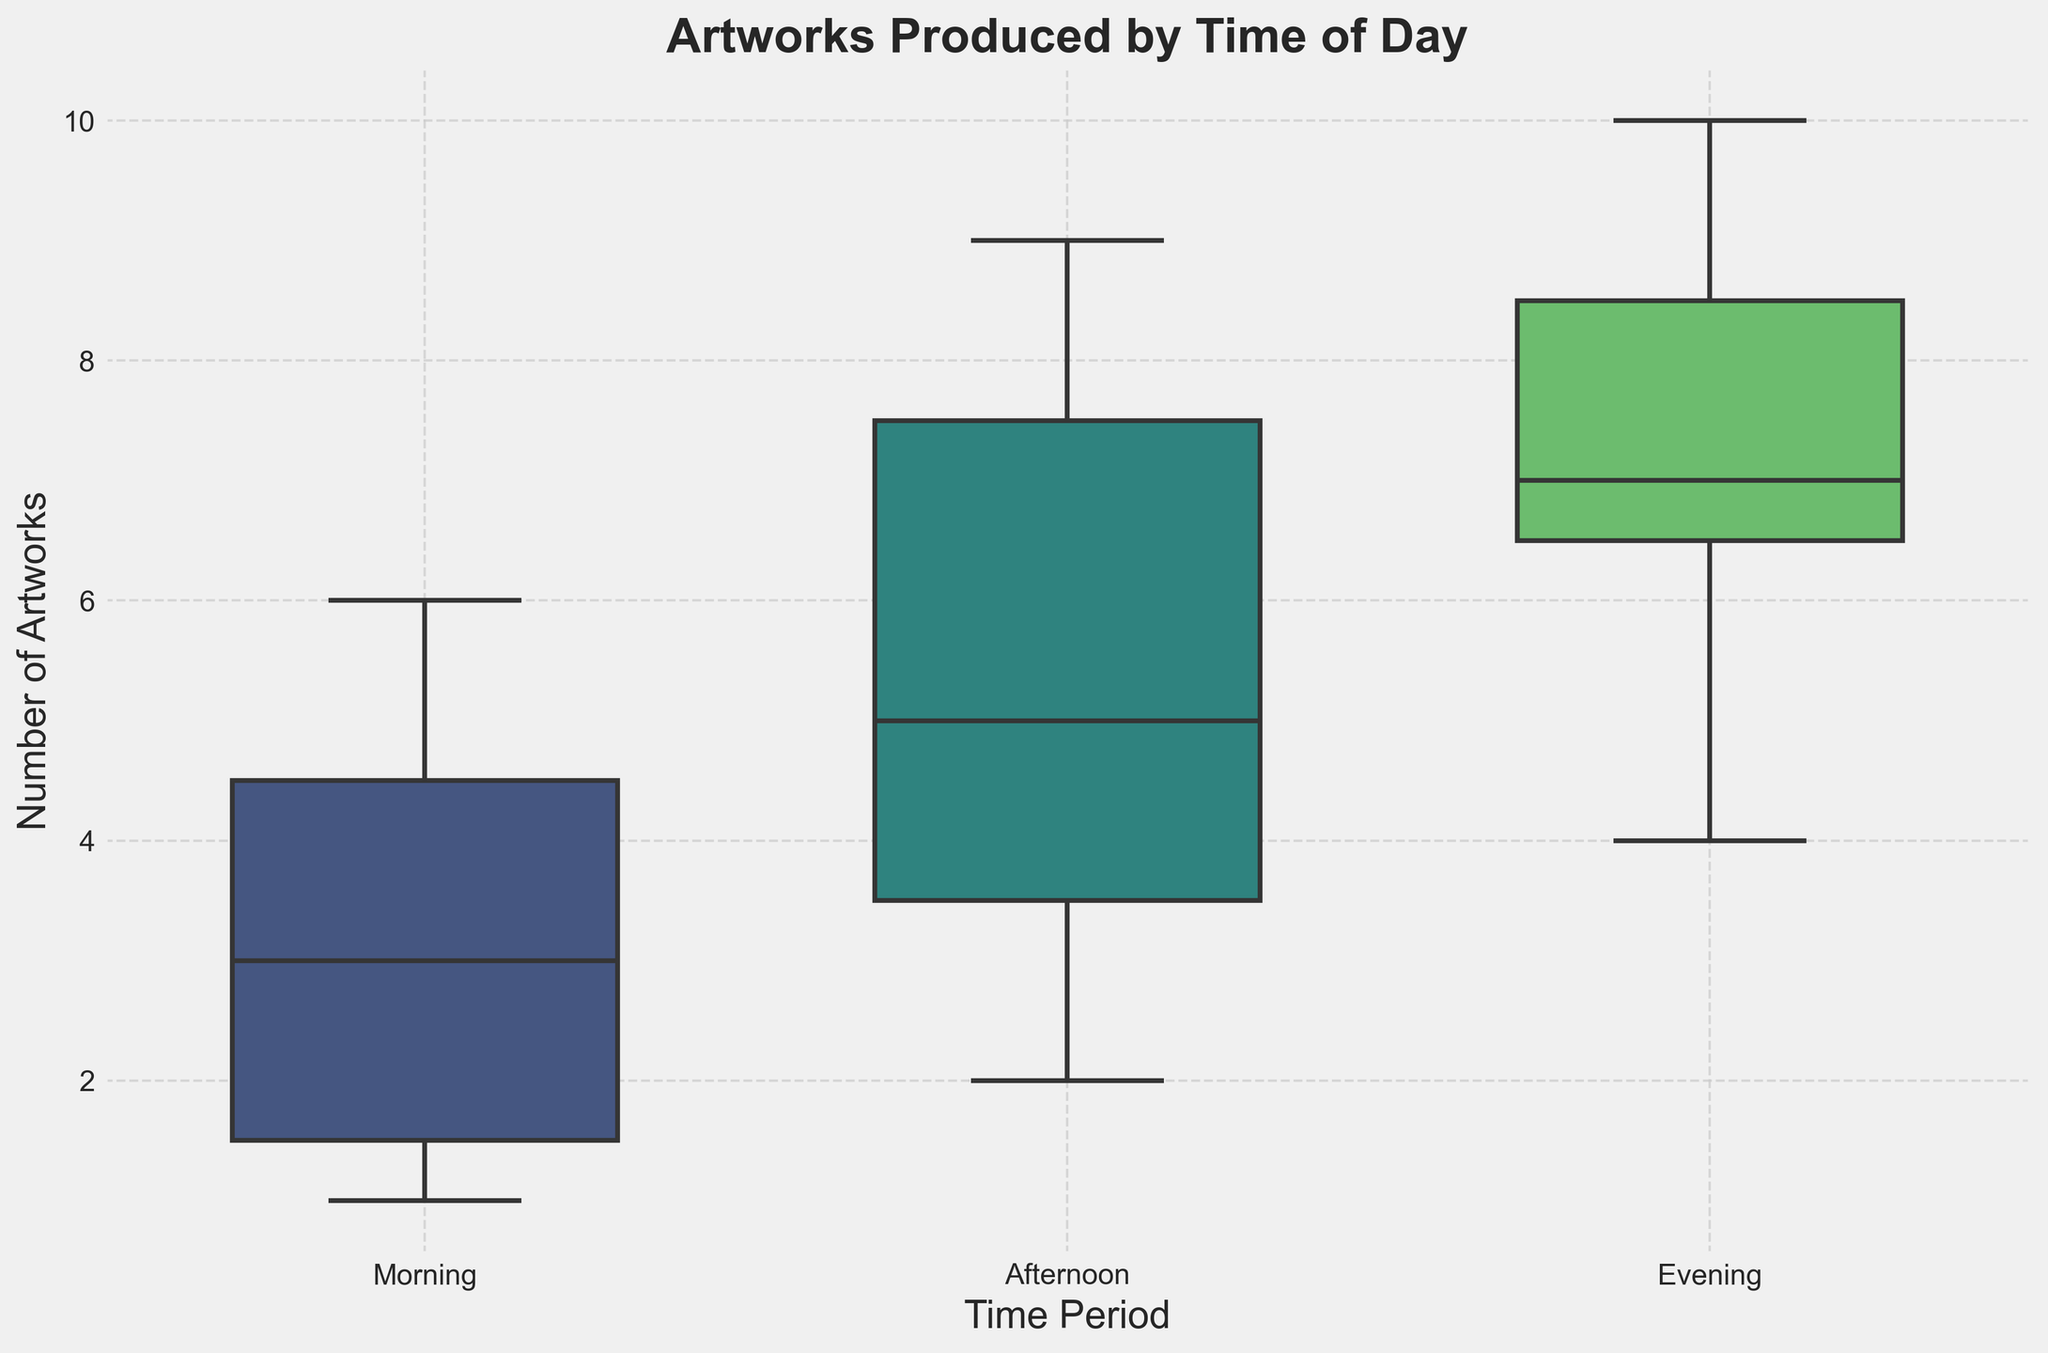What is the title of the plot? The title is usually found at the top of the plot. Here, it reads "Artworks Produced by Time of Day".
Answer: Artworks Produced by Time of Day Which time period has the highest median number of artworks produced? To find the median, look for the line inside the box for each time period. The evening time period consistently has a higher median line than morning and afternoon.
Answer: Evening How many data points are there for each time period? From the plot, one can count the individual data points or use the notches around the boxes to deduce. There are 6 data points for each of Morning, Afternoon, and Evening time periods.
Answer: 6 Are there any outliers in the morning period? Outliers appear as individual points outside the whiskers of the box plots. In this plot, there are no individual data points falling outside the whiskers of the morning period box plot.
Answer: No Which day has the lowest number of artworks produced in the Morning time period? You'll need to identify the data points for each day within the morning box plot, then find the lowest of these numbers. Sunday and Saturday morning both have the lowest number of artworks produced, which is 1. Since Sunday comes later in the week, we'll choose Sunday based on the natural progression of the weeks.
Answer: Sunday What is the interquartile range (IQR) of artworks produced in the Afternoon period? The IQR is the length of the box, which spans from the 1st quartile (bottom of the box) to the 3rd quartile (top of the box). From the plot, this range appears to be approximately from 4 to 8. So, IQR = 8 - 4.
Answer: 4 Compare the spread of artworks produced between Morning and Evening periods. Which has a wider spread? The spread can be assessed by the length of the whiskers and the size of the boxes. The Evening period generally has wider whiskers and box length, indicating a wider spread compared to the Morning period.
Answer: Evening Which time period shows the most consistency in the number of artworks produced? Consistency is seen in the narrowness of the box and smaller whiskers. The Afternoon period has the least variability, as indicated by the smaller IQR and shorter whiskers.
Answer: Afternoon 